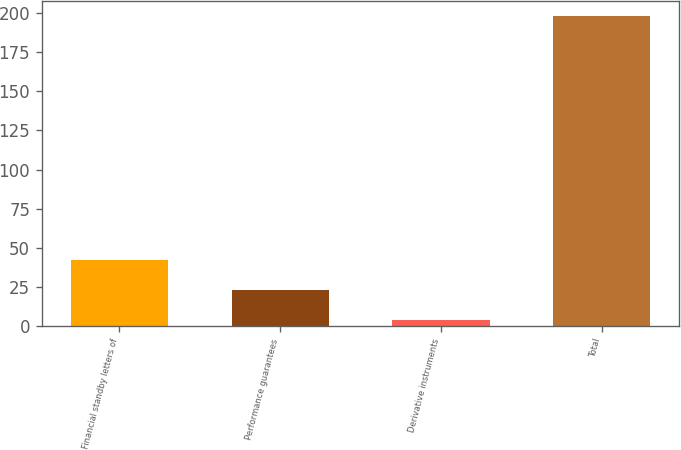<chart> <loc_0><loc_0><loc_500><loc_500><bar_chart><fcel>Financial standby letters of<fcel>Performance guarantees<fcel>Derivative instruments<fcel>Total<nl><fcel>42.48<fcel>23.04<fcel>3.6<fcel>198<nl></chart> 